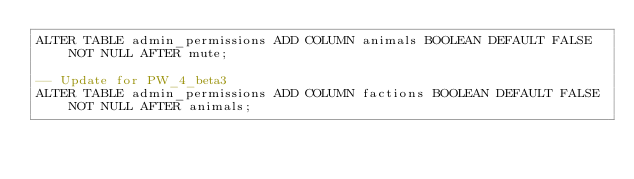<code> <loc_0><loc_0><loc_500><loc_500><_SQL_>ALTER TABLE admin_permissions ADD COLUMN animals BOOLEAN DEFAULT FALSE NOT NULL AFTER mute;

-- Update for PW_4_beta3
ALTER TABLE admin_permissions ADD COLUMN factions BOOLEAN DEFAULT FALSE NOT NULL AFTER animals;
</code> 